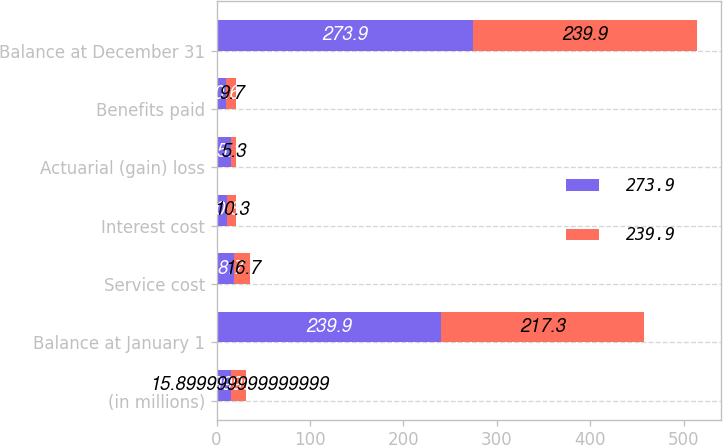<chart> <loc_0><loc_0><loc_500><loc_500><stacked_bar_chart><ecel><fcel>(in millions)<fcel>Balance at January 1<fcel>Service cost<fcel>Interest cost<fcel>Actuarial (gain) loss<fcel>Benefits paid<fcel>Balance at December 31<nl><fcel>273.9<fcel>15.9<fcel>239.9<fcel>18.7<fcel>10.8<fcel>15.1<fcel>10.6<fcel>273.9<nl><fcel>239.9<fcel>15.9<fcel>217.3<fcel>16.7<fcel>10.3<fcel>5.3<fcel>9.7<fcel>239.9<nl></chart> 